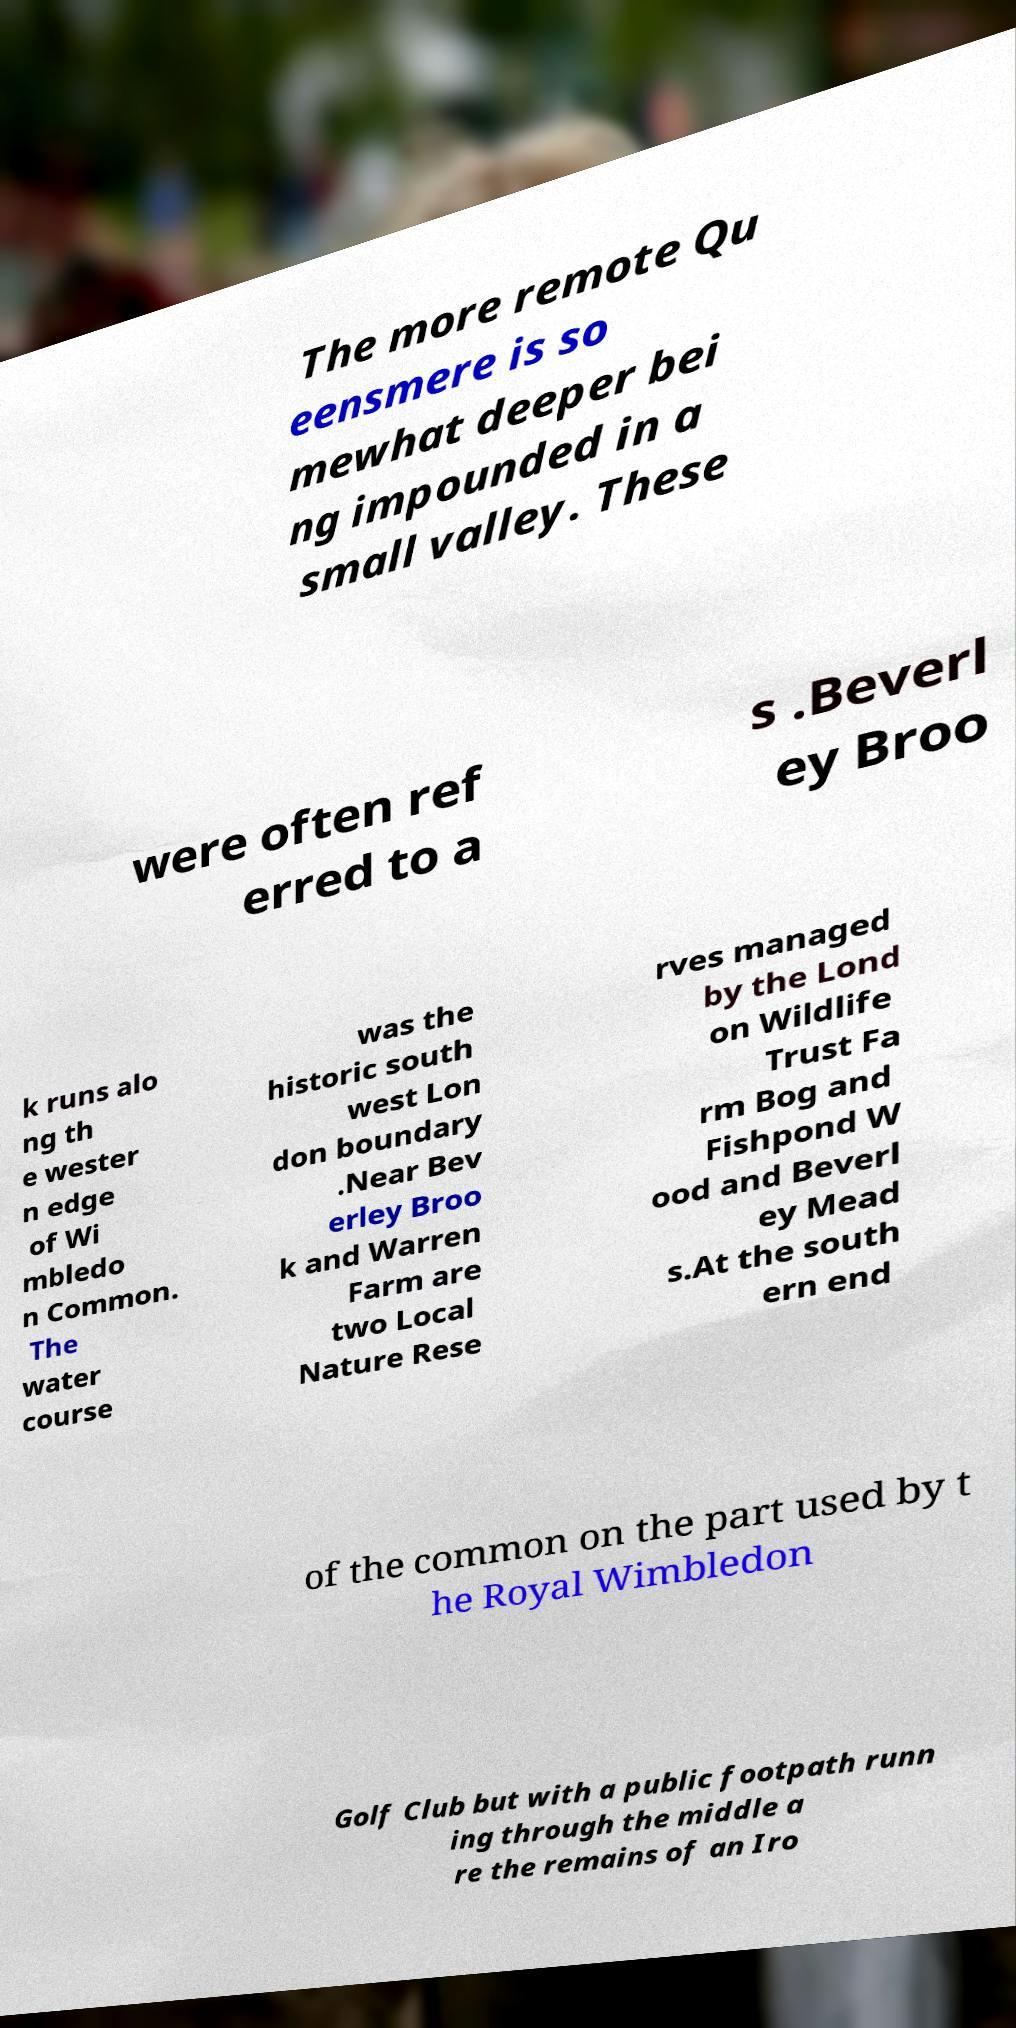Please read and relay the text visible in this image. What does it say? The more remote Qu eensmere is so mewhat deeper bei ng impounded in a small valley. These were often ref erred to a s .Beverl ey Broo k runs alo ng th e wester n edge of Wi mbledo n Common. The water course was the historic south west Lon don boundary .Near Bev erley Broo k and Warren Farm are two Local Nature Rese rves managed by the Lond on Wildlife Trust Fa rm Bog and Fishpond W ood and Beverl ey Mead s.At the south ern end of the common on the part used by t he Royal Wimbledon Golf Club but with a public footpath runn ing through the middle a re the remains of an Iro 